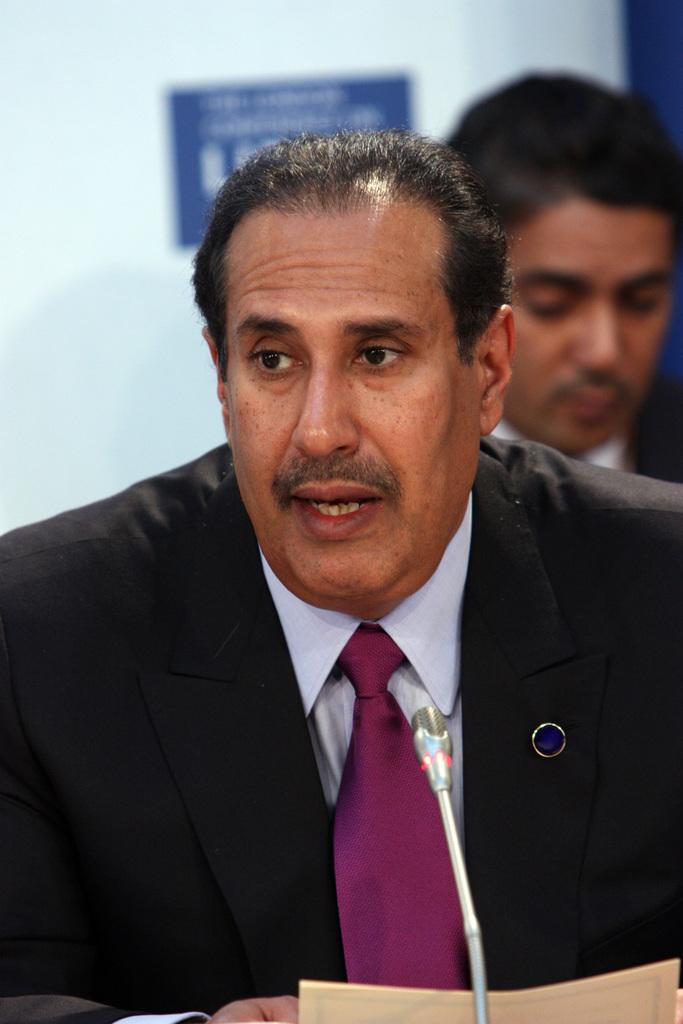Who is present in the image? There is a man in the image. What object is visible near the man? There is a microphone (mike) in the image. What is the man holding in the image? There is a paper in the image. Can you describe the person behind the man? There is a person behind the man in the image. What can be seen on the white surface in the image? There is a poster on a white surface in the image. Reasoning: Let'g: Let's think step by step in order to produce the conversation. We start by identifying the main subject in the image, which is the man. Then, we expand the conversation to include other objects and people that are also visible, such as the microphone, paper, person behind the man, and the poster on the white surface. Each question is designed to elicit a specific detail about the image that is known from the provided facts. Absurd Question/Answer: What type of thunder can be heard in the image? There is no thunder present in the image; it is a still image with no sound. 